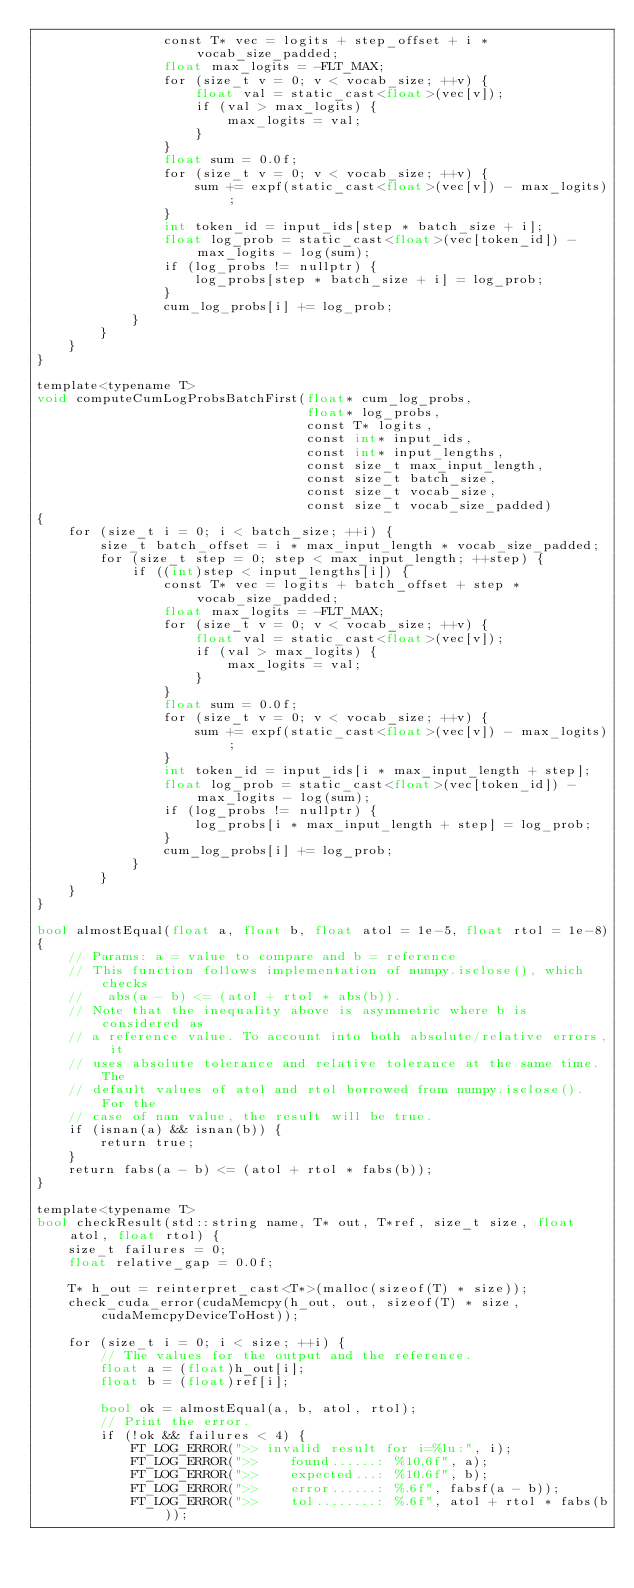Convert code to text. <code><loc_0><loc_0><loc_500><loc_500><_Cuda_>                const T* vec = logits + step_offset + i * vocab_size_padded;
                float max_logits = -FLT_MAX;
                for (size_t v = 0; v < vocab_size; ++v) {
                    float val = static_cast<float>(vec[v]);
                    if (val > max_logits) {
                        max_logits = val;
                    }
                }
                float sum = 0.0f;
                for (size_t v = 0; v < vocab_size; ++v) {
                    sum += expf(static_cast<float>(vec[v]) - max_logits);
                }
                int token_id = input_ids[step * batch_size + i];
                float log_prob = static_cast<float>(vec[token_id]) - max_logits - log(sum);
                if (log_probs != nullptr) {
                    log_probs[step * batch_size + i] = log_prob;
                }
                cum_log_probs[i] += log_prob;
            }
        }
    }
}

template<typename T>
void computeCumLogProbsBatchFirst(float* cum_log_probs,
                                  float* log_probs,
                                  const T* logits,
                                  const int* input_ids,
                                  const int* input_lengths,
                                  const size_t max_input_length,
                                  const size_t batch_size,
                                  const size_t vocab_size,
                                  const size_t vocab_size_padded)
{
    for (size_t i = 0; i < batch_size; ++i) {
        size_t batch_offset = i * max_input_length * vocab_size_padded;
        for (size_t step = 0; step < max_input_length; ++step) {
            if ((int)step < input_lengths[i]) {
                const T* vec = logits + batch_offset + step * vocab_size_padded;
                float max_logits = -FLT_MAX;
                for (size_t v = 0; v < vocab_size; ++v) {
                    float val = static_cast<float>(vec[v]);
                    if (val > max_logits) {
                        max_logits = val;
                    }
                }
                float sum = 0.0f;
                for (size_t v = 0; v < vocab_size; ++v) {
                    sum += expf(static_cast<float>(vec[v]) - max_logits);
                }
                int token_id = input_ids[i * max_input_length + step];
                float log_prob = static_cast<float>(vec[token_id]) - max_logits - log(sum);
                if (log_probs != nullptr) {
                    log_probs[i * max_input_length + step] = log_prob;
                }
                cum_log_probs[i] += log_prob;
            }
        }
    }
}

bool almostEqual(float a, float b, float atol = 1e-5, float rtol = 1e-8)
{
    // Params: a = value to compare and b = reference
    // This function follows implementation of numpy.isclose(), which checks
    //   abs(a - b) <= (atol + rtol * abs(b)).
    // Note that the inequality above is asymmetric where b is considered as
    // a reference value. To account into both absolute/relative errors, it
    // uses absolute tolerance and relative tolerance at the same time. The
    // default values of atol and rtol borrowed from numpy.isclose(). For the
    // case of nan value, the result will be true.
    if (isnan(a) && isnan(b)) {
        return true;
    }
    return fabs(a - b) <= (atol + rtol * fabs(b));
}

template<typename T>
bool checkResult(std::string name, T* out, T*ref, size_t size, float atol, float rtol) {
    size_t failures = 0;
    float relative_gap = 0.0f;

    T* h_out = reinterpret_cast<T*>(malloc(sizeof(T) * size));
    check_cuda_error(cudaMemcpy(h_out, out, sizeof(T) * size, cudaMemcpyDeviceToHost));

    for (size_t i = 0; i < size; ++i) {
        // The values for the output and the reference.
        float a = (float)h_out[i];
        float b = (float)ref[i];

        bool ok = almostEqual(a, b, atol, rtol);
        // Print the error.
        if (!ok && failures < 4) {
            FT_LOG_ERROR(">> invalid result for i=%lu:", i);
            FT_LOG_ERROR(">>    found......: %10.6f", a);
            FT_LOG_ERROR(">>    expected...: %10.6f", b);
            FT_LOG_ERROR(">>    error......: %.6f", fabsf(a - b));
            FT_LOG_ERROR(">>    tol........: %.6f", atol + rtol * fabs(b));</code> 